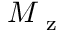Convert formula to latex. <formula><loc_0><loc_0><loc_500><loc_500>M _ { z }</formula> 